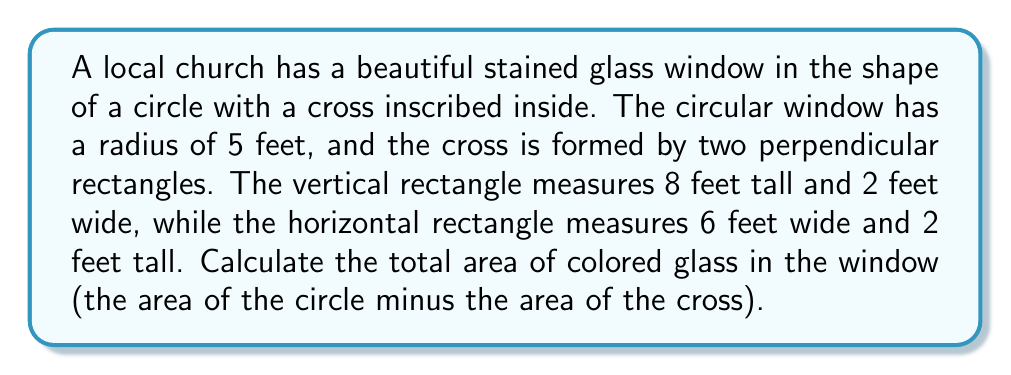Can you answer this question? Let's approach this step-by-step:

1. Calculate the area of the circular window:
   $$A_{circle} = \pi r^2 = \pi (5 \text{ ft})^2 = 25\pi \text{ ft}^2$$

2. Calculate the area of the vertical rectangle:
   $$A_{vertical} = 8 \text{ ft} \times 2 \text{ ft} = 16 \text{ ft}^2$$

3. Calculate the area of the horizontal rectangle:
   $$A_{horizontal} = 6 \text{ ft} \times 2 \text{ ft} = 12 \text{ ft}^2$$

4. Calculate the total area of the cross:
   $$A_{cross} = A_{vertical} + A_{horizontal} - A_{overlap}$$
   where $A_{overlap}$ is the area where the rectangles intersect.
   
   The overlap is a 2 ft × 2 ft square:
   $$A_{overlap} = 2 \text{ ft} \times 2 \text{ ft} = 4 \text{ ft}^2$$

   Therefore,
   $$A_{cross} = 16 \text{ ft}^2 + 12 \text{ ft}^2 - 4 \text{ ft}^2 = 24 \text{ ft}^2$$

5. Calculate the area of colored glass:
   $$A_{colored} = A_{circle} - A_{cross} = 25\pi \text{ ft}^2 - 24 \text{ ft}^2$$

6. Simplify:
   $$A_{colored} = 25\pi \text{ ft}^2 - 24 \text{ ft}^2 \approx 54.51 \text{ ft}^2$$
Answer: $25\pi - 24 \approx 54.51 \text{ ft}^2$ 